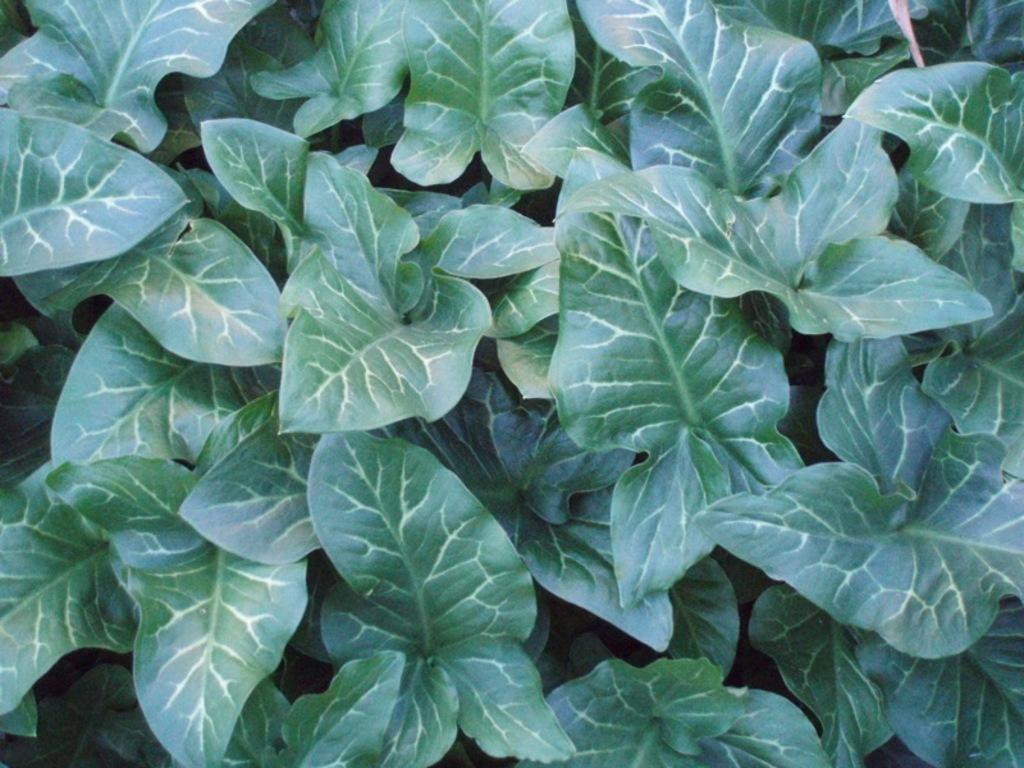What type of living organisms can be seen in the image? Plants can be seen in the image. What trick is the plant performing in the image? There is no trick being performed by the plant in the image, as plants do not have the ability to perform tricks. 